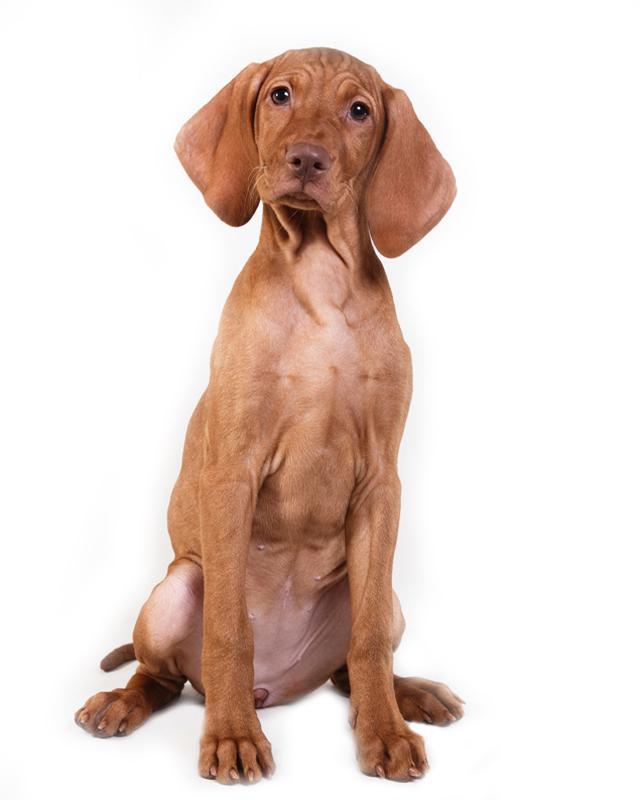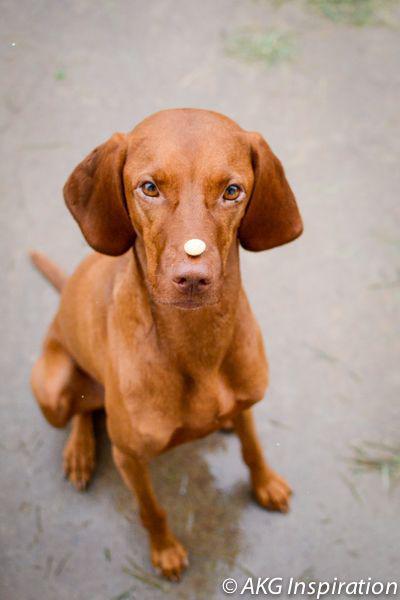The first image is the image on the left, the second image is the image on the right. Examine the images to the left and right. Is the description "Each image contains only one dog and it is sitting" accurate? Answer yes or no. Yes. The first image is the image on the left, the second image is the image on the right. Assess this claim about the two images: "Each image includes a red-orange dog with floppy ears in an upright sitting position, the dog depicted in the left image is facing forward, and a dog depicted in the right image has something on top of its muzzle.". Correct or not? Answer yes or no. Yes. 